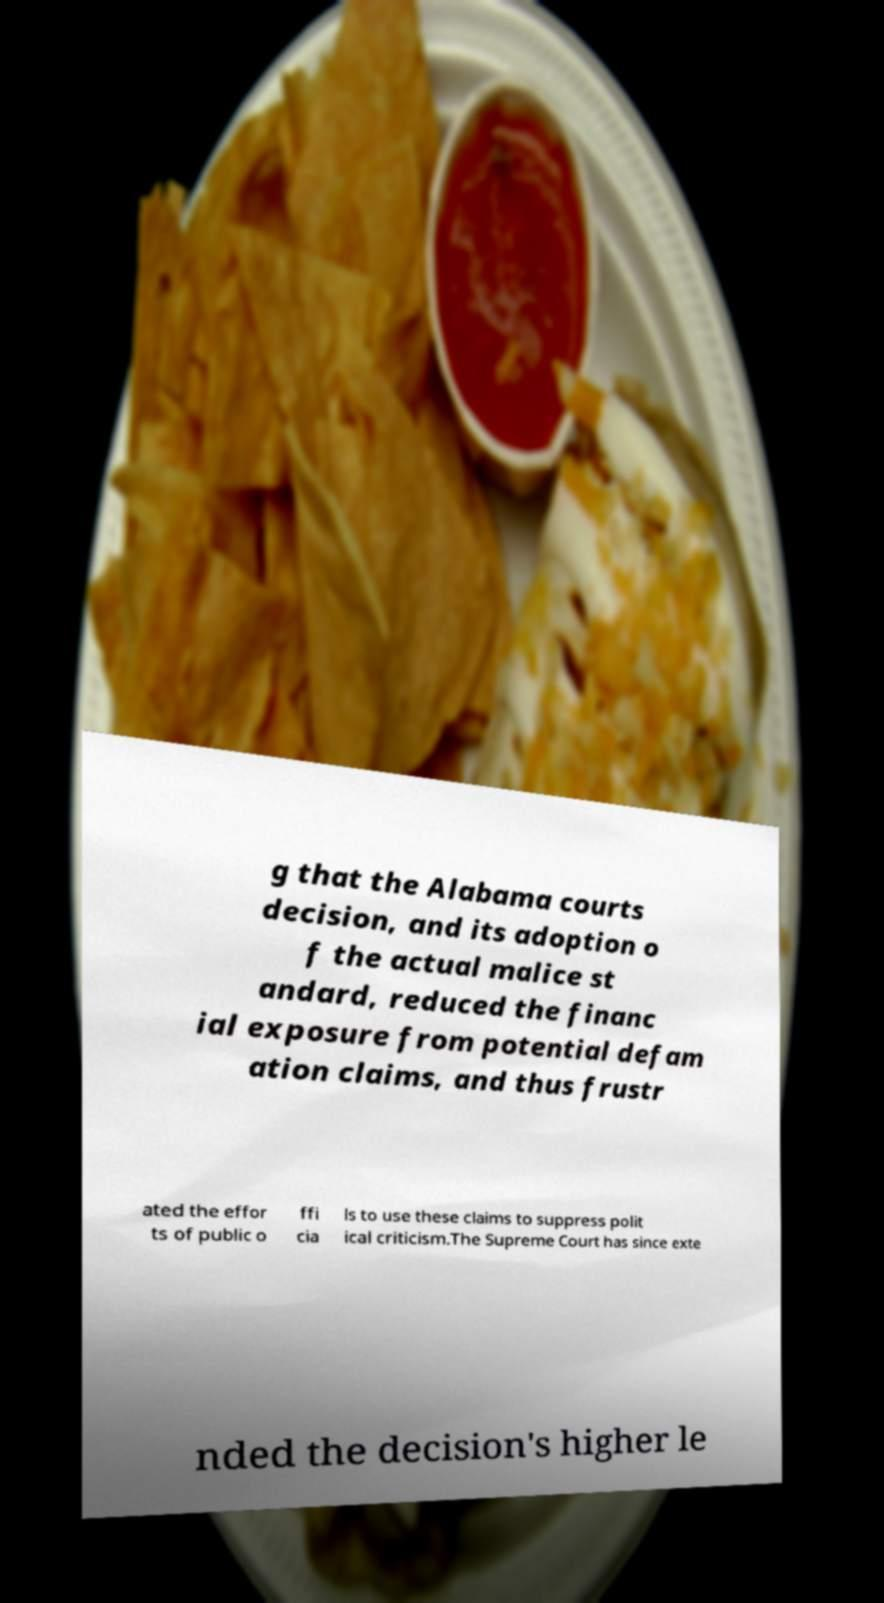There's text embedded in this image that I need extracted. Can you transcribe it verbatim? g that the Alabama courts decision, and its adoption o f the actual malice st andard, reduced the financ ial exposure from potential defam ation claims, and thus frustr ated the effor ts of public o ffi cia ls to use these claims to suppress polit ical criticism.The Supreme Court has since exte nded the decision's higher le 